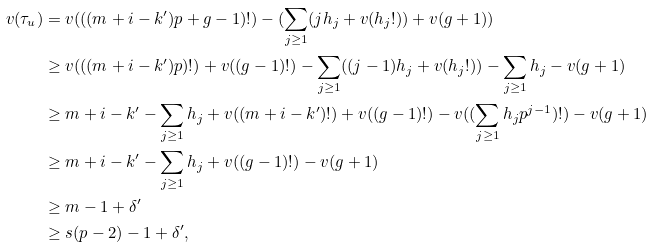Convert formula to latex. <formula><loc_0><loc_0><loc_500><loc_500>v ( \tau _ { u } ) & = v ( ( ( m + i - k ^ { \prime } ) p + g - 1 ) ! ) - ( \sum _ { j \geq 1 } ( j h _ { j } + v ( h _ { j } ! ) ) + v ( g + 1 ) ) \\ & \geq v ( ( ( m + i - k ^ { \prime } ) p ) ! ) + v ( ( g - 1 ) ! ) - \sum _ { j \geq 1 } ( ( j - 1 ) h _ { j } + v ( h _ { j } ! ) ) - \sum _ { j \geq 1 } h _ { j } - v ( g + 1 ) \\ & \geq m + i - k ^ { \prime } - \sum _ { j \geq 1 } h _ { j } + v ( ( m + i - k ^ { \prime } ) ! ) + v ( ( g - 1 ) ! ) - v ( ( \sum _ { j \geq 1 } h _ { j } p ^ { j - 1 } ) ! ) - v ( g + 1 ) \\ & \geq m + i - k ^ { \prime } - \sum _ { j \geq 1 } h _ { j } + v ( ( g - 1 ) ! ) - v ( g + 1 ) \\ & \geq m - 1 + \delta ^ { \prime } \\ & \geq s ( p - 2 ) - 1 + \delta ^ { \prime } ,</formula> 